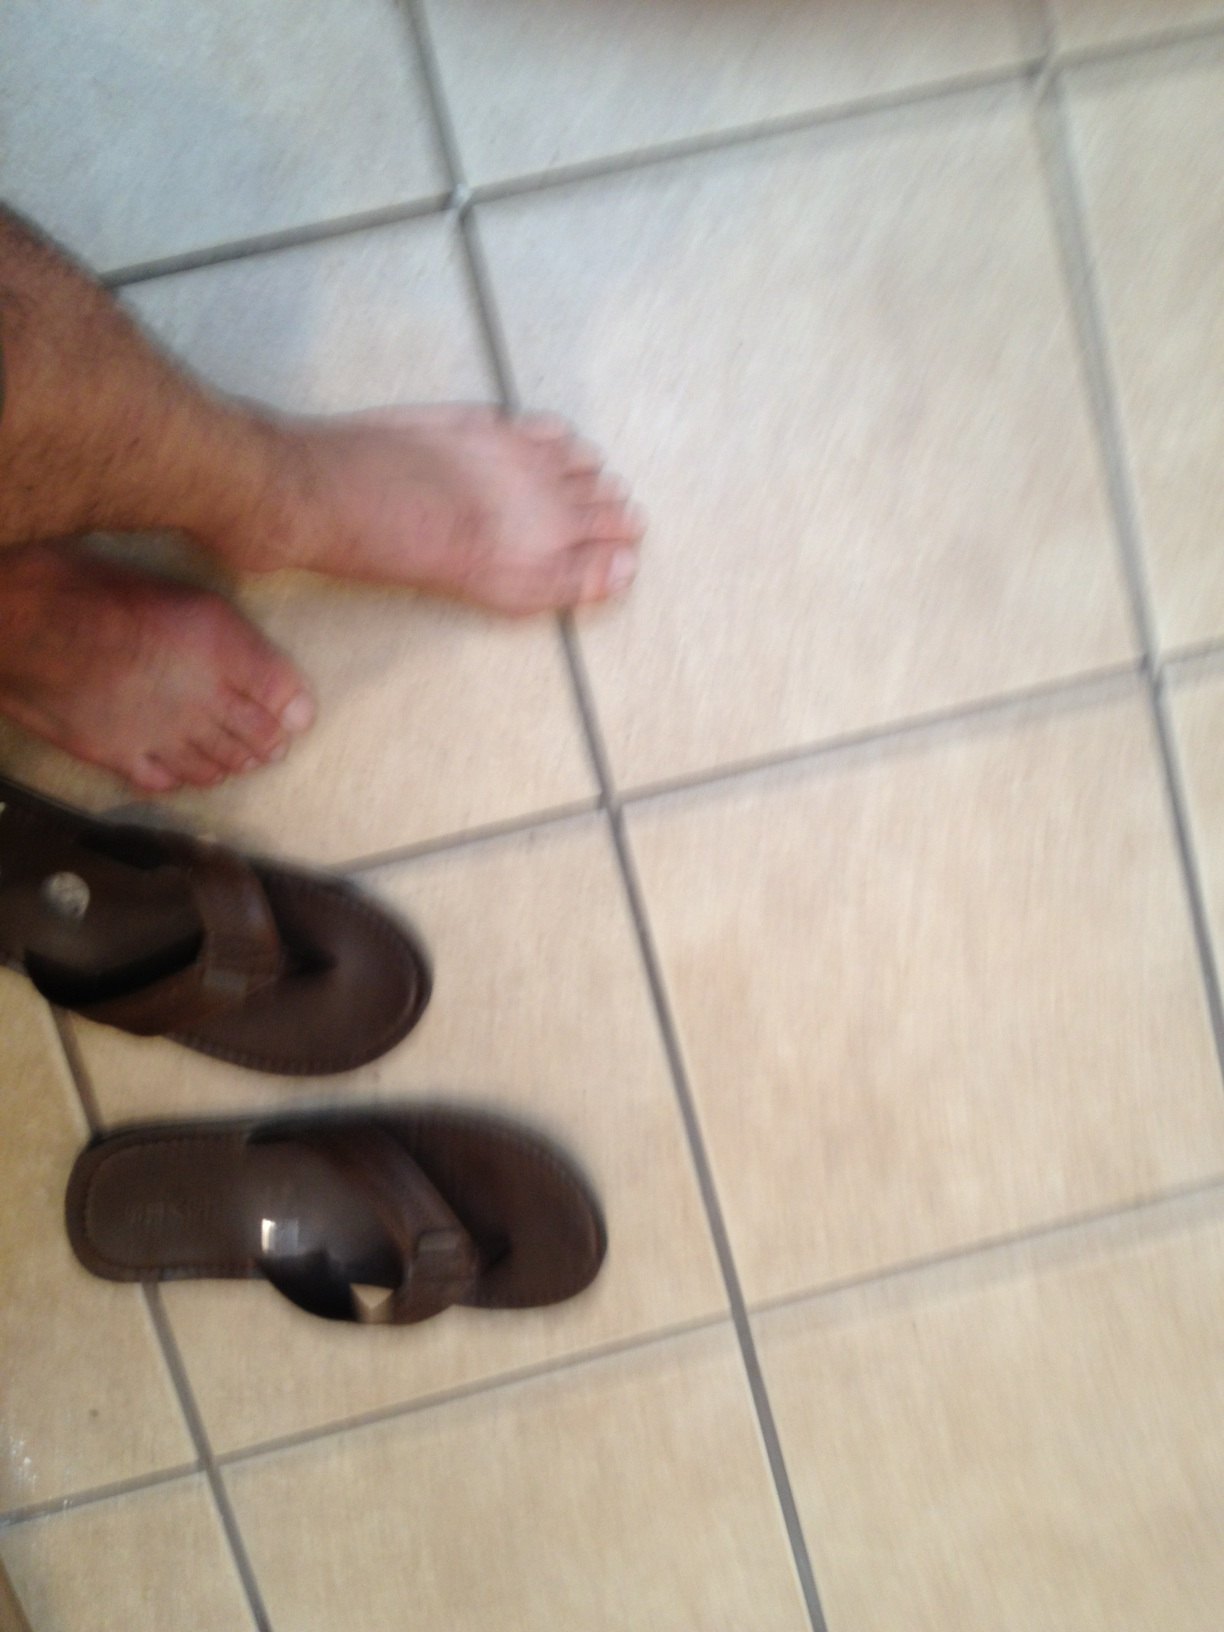Where might these flip flops be commonly used? Flip flops like these are typically used in informal settings such as at home, at the beach, or during leisure activities in warm weather. Their ease of slipping on and off makes them a popular choice for casual wear. 